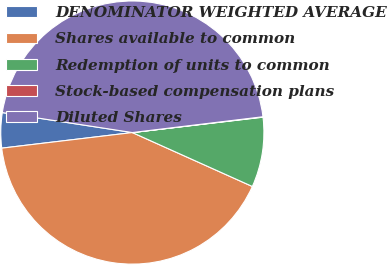Convert chart. <chart><loc_0><loc_0><loc_500><loc_500><pie_chart><fcel>DENOMINATOR WEIGHTED AVERAGE<fcel>Shares available to common<fcel>Redemption of units to common<fcel>Stock-based compensation plans<fcel>Diluted Shares<nl><fcel>4.32%<fcel>41.39%<fcel>8.59%<fcel>0.05%<fcel>45.66%<nl></chart> 